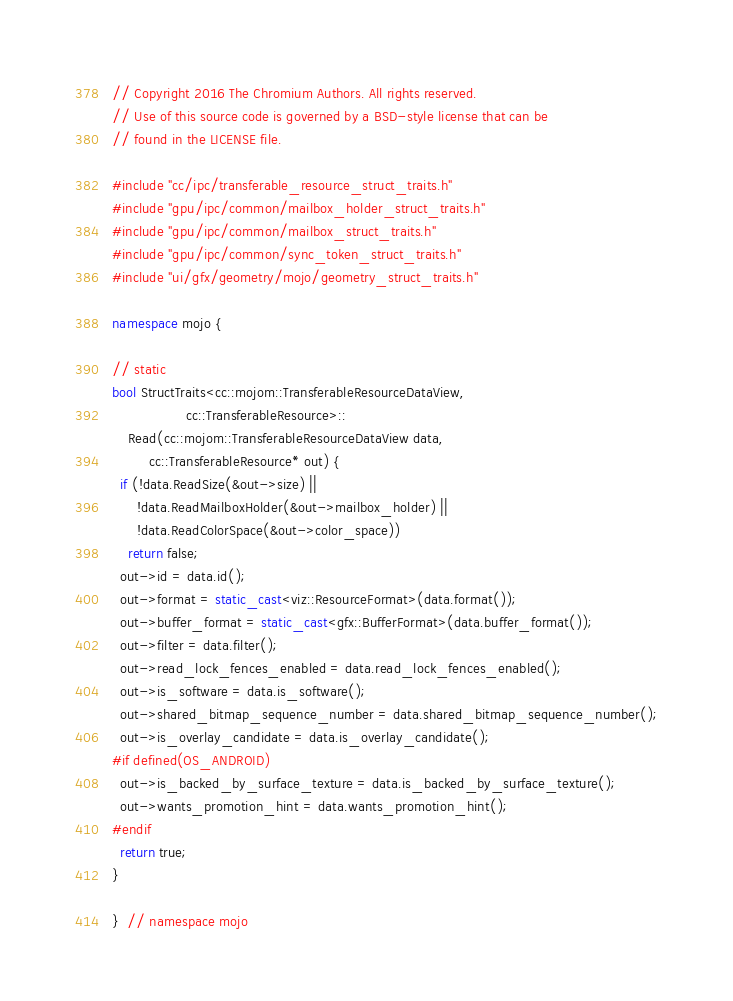<code> <loc_0><loc_0><loc_500><loc_500><_C++_>// Copyright 2016 The Chromium Authors. All rights reserved.
// Use of this source code is governed by a BSD-style license that can be
// found in the LICENSE file.

#include "cc/ipc/transferable_resource_struct_traits.h"
#include "gpu/ipc/common/mailbox_holder_struct_traits.h"
#include "gpu/ipc/common/mailbox_struct_traits.h"
#include "gpu/ipc/common/sync_token_struct_traits.h"
#include "ui/gfx/geometry/mojo/geometry_struct_traits.h"

namespace mojo {

// static
bool StructTraits<cc::mojom::TransferableResourceDataView,
                  cc::TransferableResource>::
    Read(cc::mojom::TransferableResourceDataView data,
         cc::TransferableResource* out) {
  if (!data.ReadSize(&out->size) ||
      !data.ReadMailboxHolder(&out->mailbox_holder) ||
      !data.ReadColorSpace(&out->color_space))
    return false;
  out->id = data.id();
  out->format = static_cast<viz::ResourceFormat>(data.format());
  out->buffer_format = static_cast<gfx::BufferFormat>(data.buffer_format());
  out->filter = data.filter();
  out->read_lock_fences_enabled = data.read_lock_fences_enabled();
  out->is_software = data.is_software();
  out->shared_bitmap_sequence_number = data.shared_bitmap_sequence_number();
  out->is_overlay_candidate = data.is_overlay_candidate();
#if defined(OS_ANDROID)
  out->is_backed_by_surface_texture = data.is_backed_by_surface_texture();
  out->wants_promotion_hint = data.wants_promotion_hint();
#endif
  return true;
}

}  // namespace mojo
</code> 